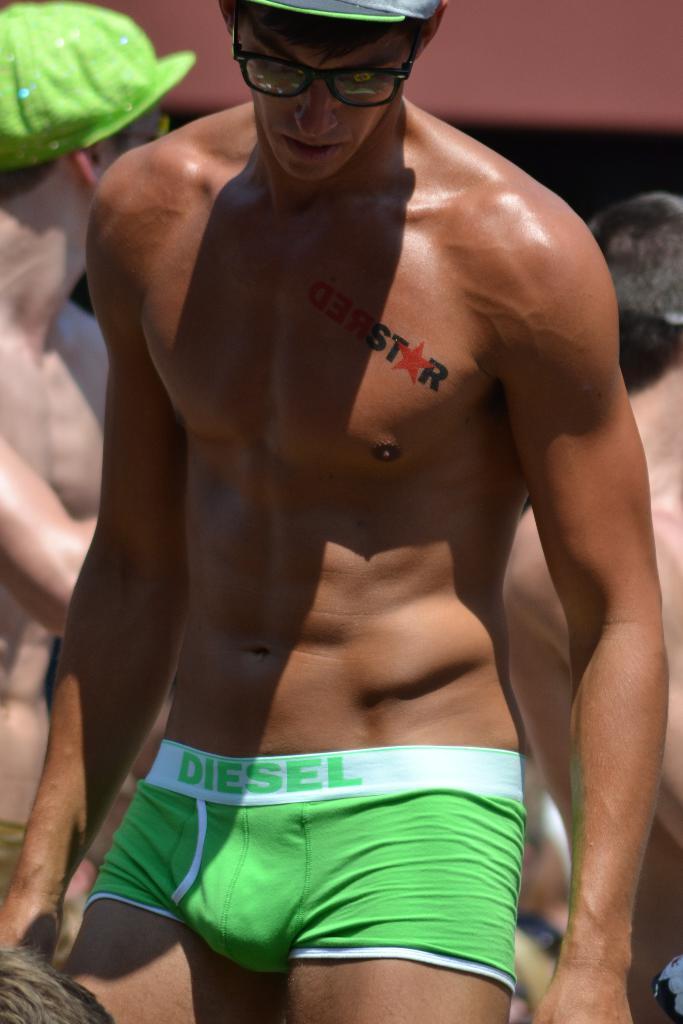What brand of clothing is he wearing?
Provide a succinct answer. Diesel. 